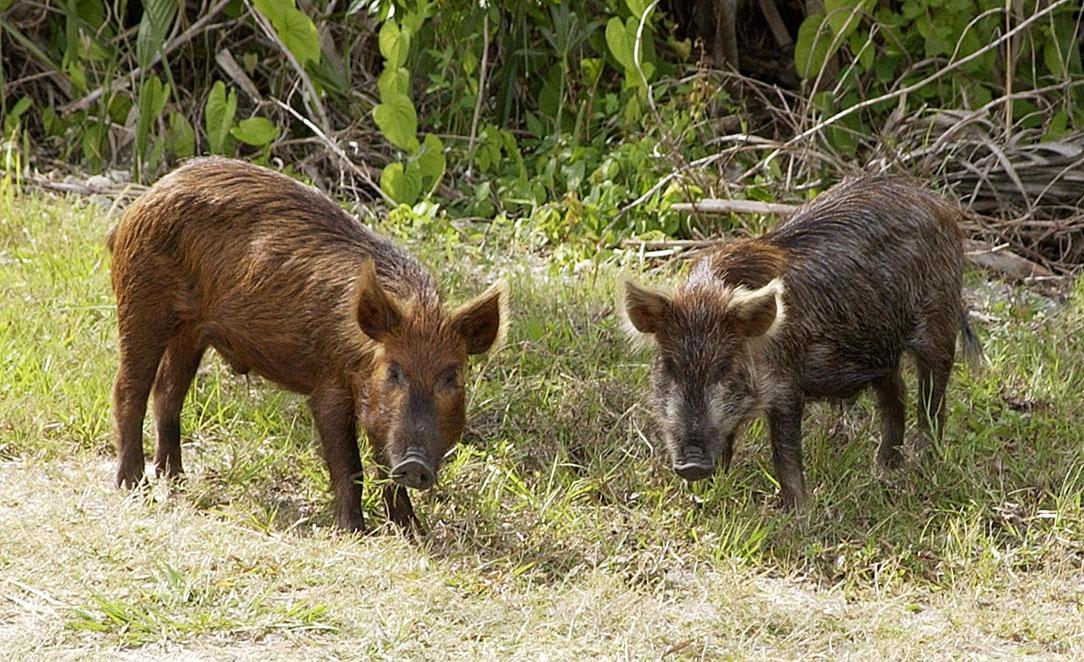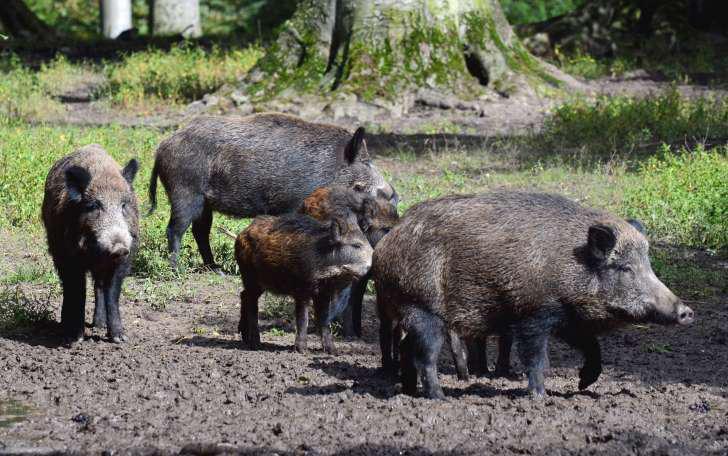The first image is the image on the left, the second image is the image on the right. Evaluate the accuracy of this statement regarding the images: "An image contains no more than two warthogs, which face forward.". Is it true? Answer yes or no. Yes. 